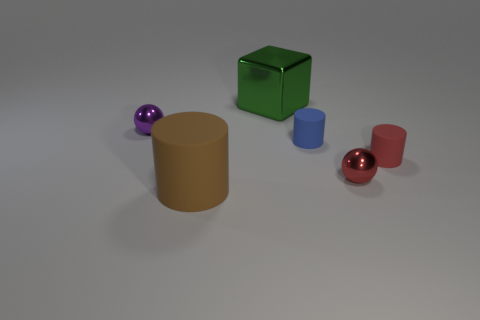Add 3 big purple spheres. How many objects exist? 9 Subtract all spheres. How many objects are left? 4 Subtract 0 purple blocks. How many objects are left? 6 Subtract all purple metallic objects. Subtract all small purple shiny things. How many objects are left? 4 Add 2 blocks. How many blocks are left? 3 Add 5 tiny balls. How many tiny balls exist? 7 